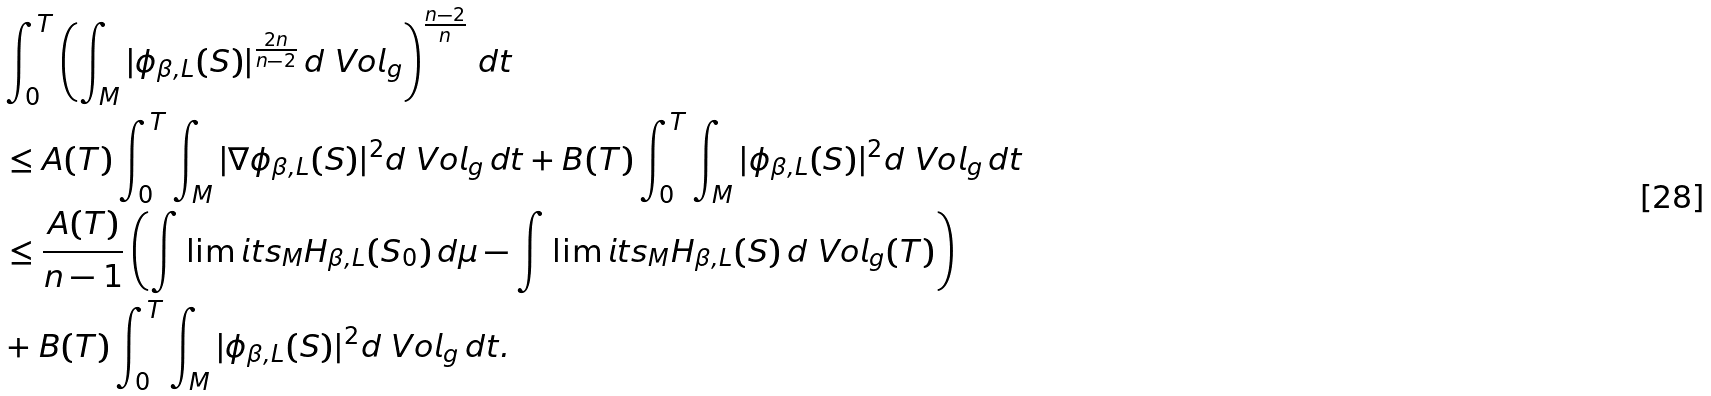Convert formula to latex. <formula><loc_0><loc_0><loc_500><loc_500>& \int _ { 0 } ^ { T } \left ( \int _ { M } | \phi _ { \beta , L } ( S ) | ^ { \frac { 2 n } { n - 2 } } \, d \ V o l _ { g } \right ) ^ { \frac { n - 2 } { n } } \, d t \\ & \leq A ( T ) \int _ { 0 } ^ { T } \int _ { M } | \nabla \phi _ { \beta , L } ( S ) | ^ { 2 } d \ V o l _ { g } \, d t + B ( T ) \int _ { 0 } ^ { T } \int _ { M } | \phi _ { \beta , L } ( S ) | ^ { 2 } d \ V o l _ { g } \, d t \\ & \leq \frac { A ( T ) } { n - 1 } \left ( \int \lim i t s _ { M } H _ { \beta , L } ( S _ { 0 } ) \, d \mu - \int \lim i t s _ { M } H _ { \beta , L } ( S ) \, d \ V o l _ { g } ( T ) \right ) \\ & + B ( T ) \int _ { 0 } ^ { T } \int _ { M } | \phi _ { \beta , L } ( S ) | ^ { 2 } d \ V o l _ { g } \, d t .</formula> 